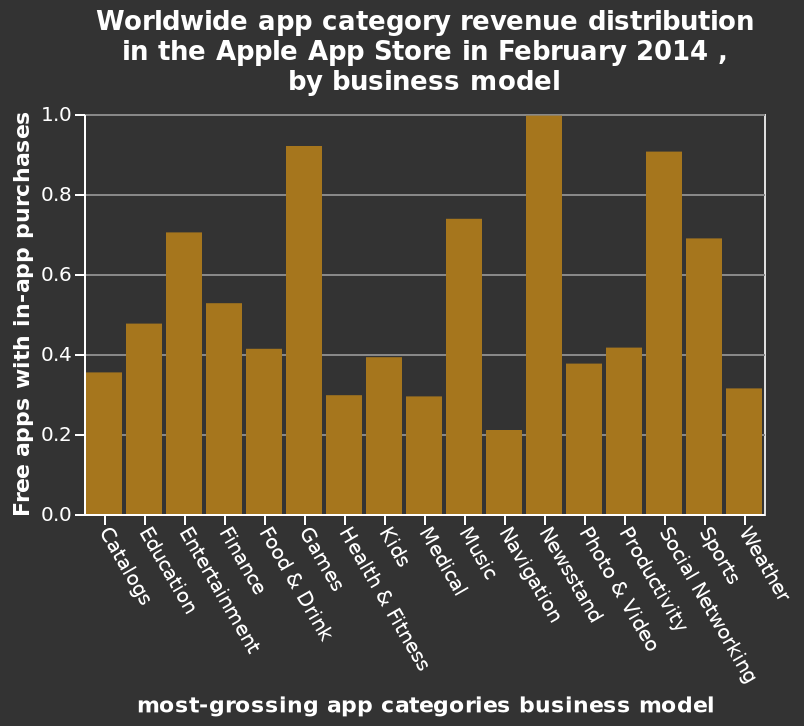<image>
please summary the statistics and relations of the chart The bar chart shows most revenue for apple apps is created by gaming, then news and social networking. The lowest amount of revenue from the app store is from navigation. What is shown on the x-axis of the graph?  The x-axis of the graph shows the app categories labeled from Catalogs to Weather, representing the most-grossing app categories business model. What type of apps generates the most revenue for Apple? Gaming apps generate the most revenue for Apple. Does the bar chart show most revenue for apple apps is created by navigation, then gaming and social networking? No.The bar chart shows most revenue for apple apps is created by gaming, then news and social networking. The lowest amount of revenue from the app store is from navigation. 